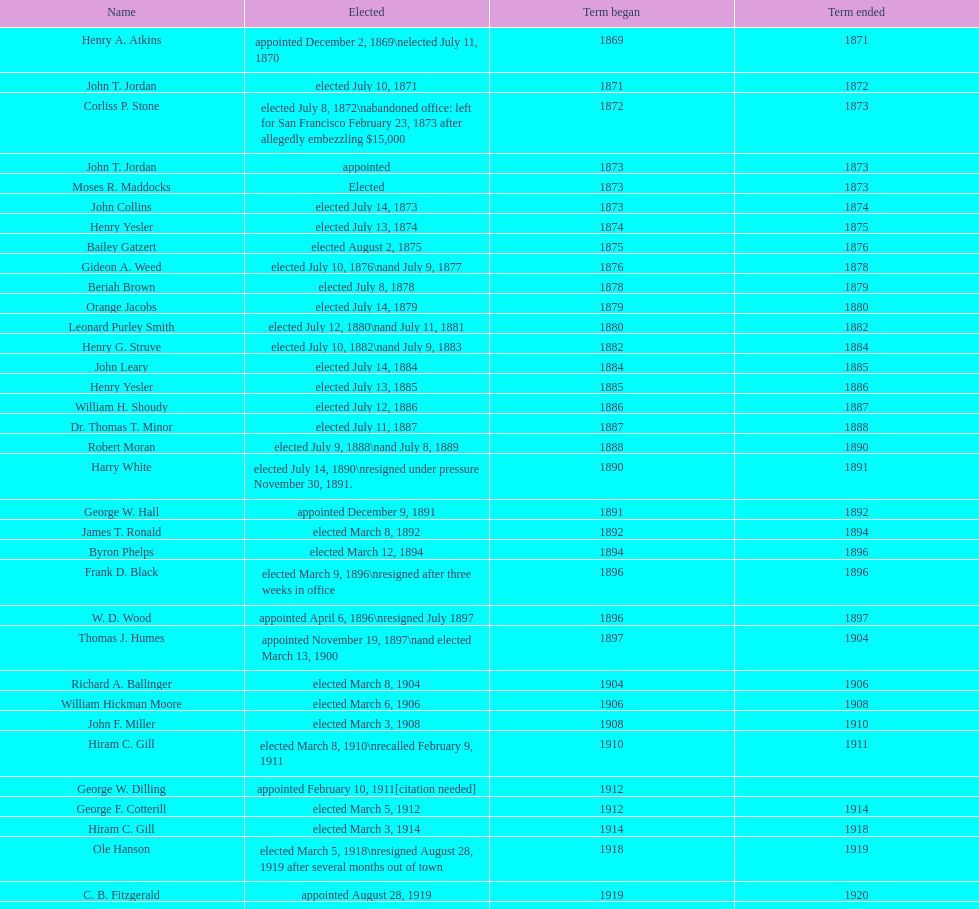Who held the mayoral office in seattle, washington before taking up a role in the department of transportation during nixon's presidency? James d'Orma Braman. 